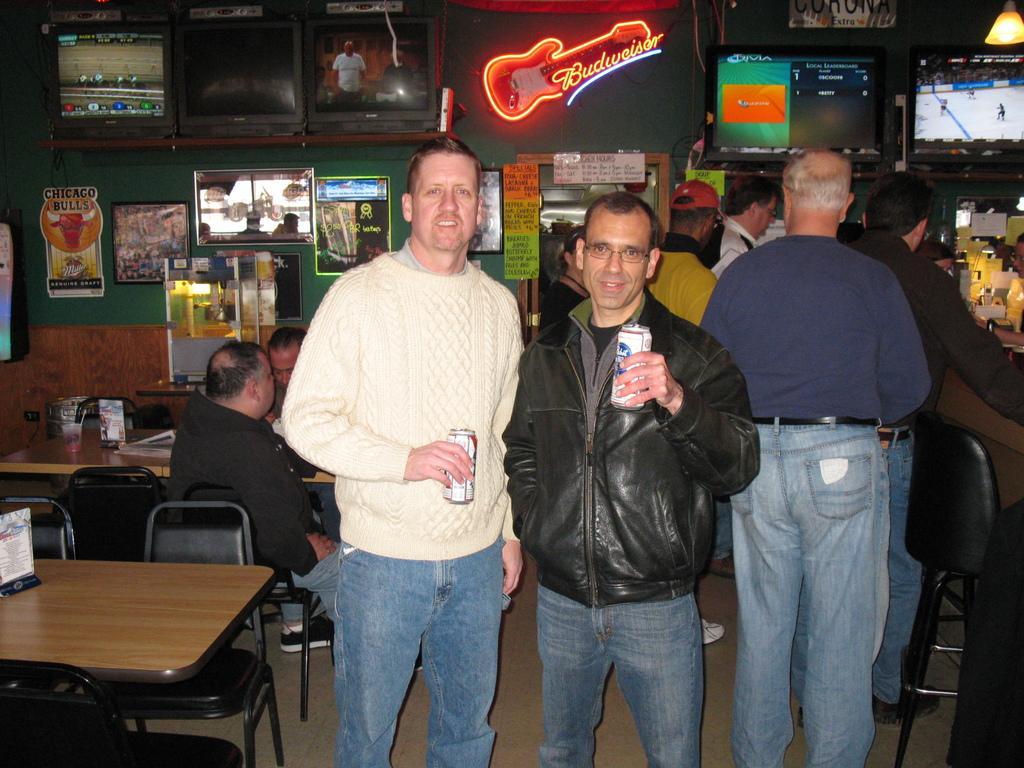Please provide a concise description of this image. This image is clicked in a restaurant. There are many people in this image. In the front, the men stand standing are holding things in their hands. To the left, there is a table along with chair. In the background, there is a wall in green color. On which there are many frames attached and there is a rack on which TVs are placed. 